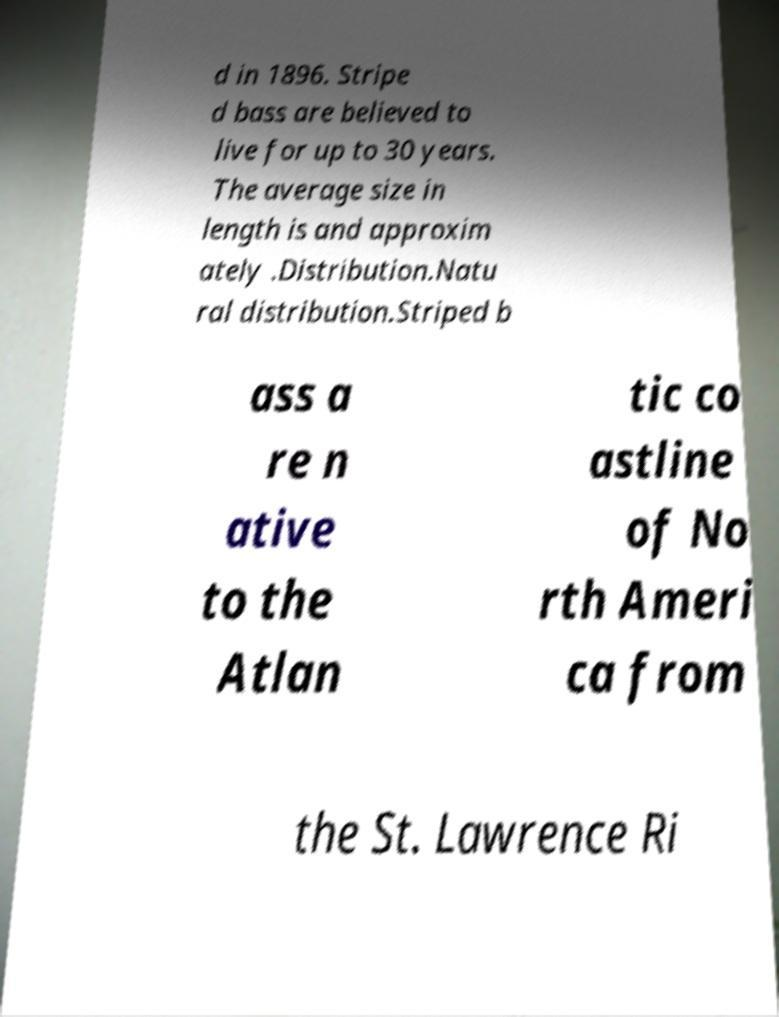Can you read and provide the text displayed in the image?This photo seems to have some interesting text. Can you extract and type it out for me? d in 1896. Stripe d bass are believed to live for up to 30 years. The average size in length is and approxim ately .Distribution.Natu ral distribution.Striped b ass a re n ative to the Atlan tic co astline of No rth Ameri ca from the St. Lawrence Ri 